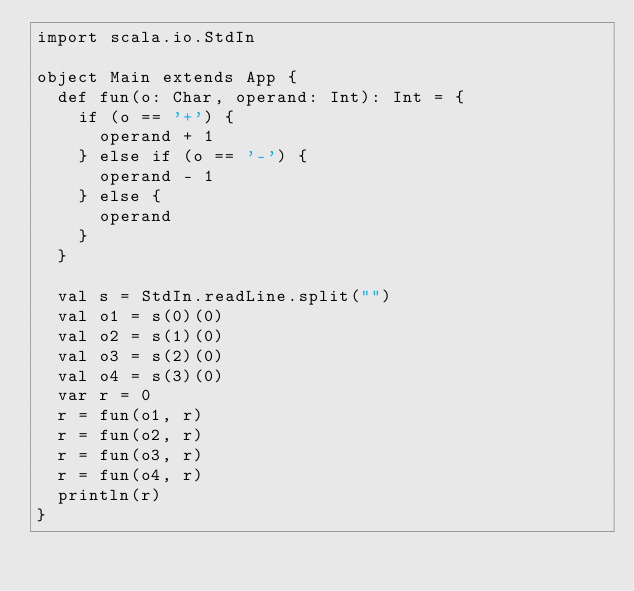<code> <loc_0><loc_0><loc_500><loc_500><_Scala_>import scala.io.StdIn

object Main extends App {
  def fun(o: Char, operand: Int): Int = {
    if (o == '+') {
      operand + 1
    } else if (o == '-') {
      operand - 1
    } else {
      operand
    }
  }

  val s = StdIn.readLine.split("")
  val o1 = s(0)(0)
  val o2 = s(1)(0)
  val o3 = s(2)(0)
  val o4 = s(3)(0)
  var r = 0
  r = fun(o1, r)
  r = fun(o2, r)
  r = fun(o3, r)
  r = fun(o4, r)
  println(r)
}</code> 